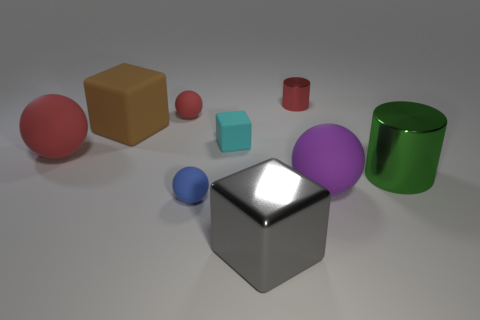What material is the tiny ball that is the same color as the tiny cylinder?
Provide a short and direct response. Rubber. Is there a thing that has the same color as the tiny cylinder?
Provide a short and direct response. Yes. The shiny cube is what color?
Offer a very short reply. Gray. Are there any other things that are the same shape as the green thing?
Ensure brevity in your answer.  Yes. What color is the other rubber object that is the same shape as the cyan matte object?
Offer a very short reply. Brown. Is the large gray thing the same shape as the tiny red metal object?
Your answer should be compact. No. What number of blocks are either large gray objects or large brown rubber things?
Keep it short and to the point. 2. There is a cube that is made of the same material as the cyan object; what is its color?
Ensure brevity in your answer.  Brown. There is a green metal object in front of the brown object; does it have the same size as the small blue rubber sphere?
Keep it short and to the point. No. Does the purple sphere have the same material as the large thing that is behind the tiny cyan matte object?
Provide a short and direct response. Yes. 